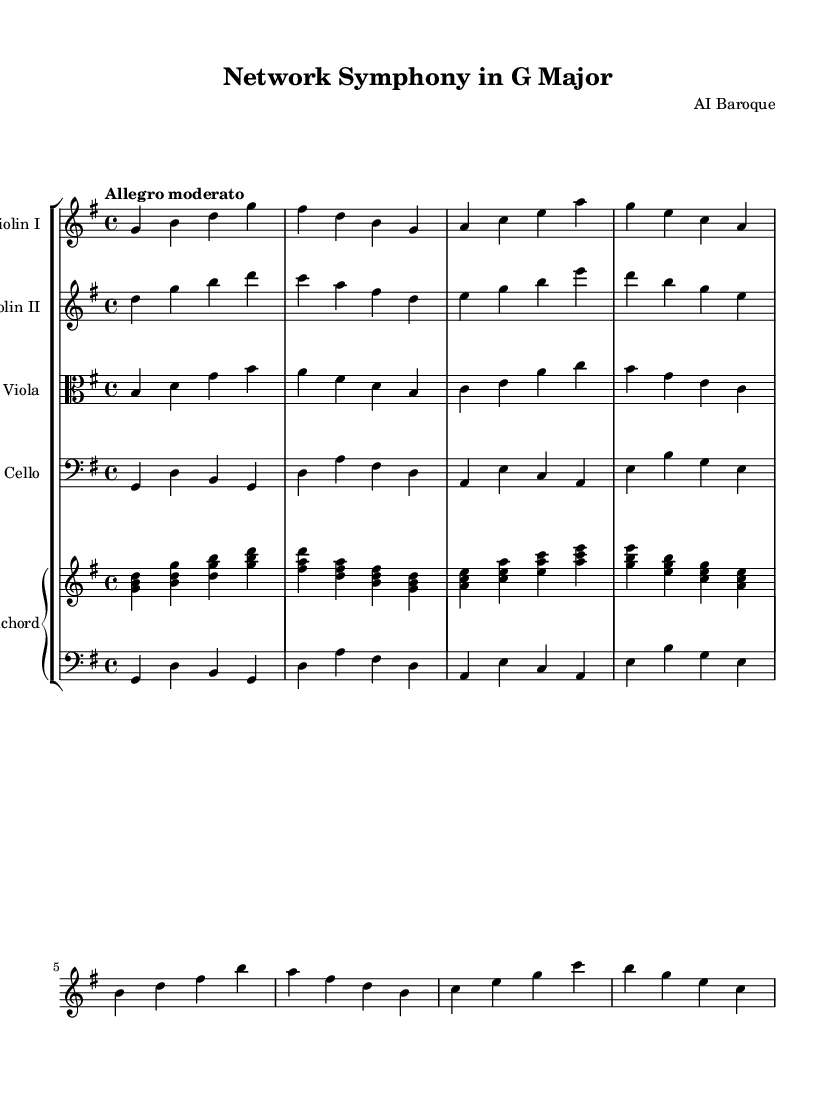What is the key signature of this music? The key signature is G major, which has one sharp (F#). You can determine the key by looking at the key signature at the beginning of the staff, which shows one sharp.
Answer: G major What is the time signature of this music? The time signature is 4/4, which indicates four beats per measure and a quarter note receives one beat. This can be found at the beginning of the score right after the key signature.
Answer: 4/4 What is the tempo marking for this piece? The tempo marking is "Allegro moderato." This information is provided at the beginning of the score and indicates the speed and character at which the piece should be played.
Answer: Allegro moderato How many instruments are featured in this composition? There are five instruments featured in the composition: two violins, one viola, one cello, and one harpsichord. This can be seen at the start of each staff group, where the instruments are named.
Answer: Five Which instrument plays the bass line primarily? The cello primarily plays the bass line in this composition. The music written for the cello is located in the lowest staff, confirming its role in providing the bass foundation.
Answer: Cello What type of musical form is suggested by the variation of textures among the instruments? The music suggests a dialogue or interchange, often found in Baroque chamber music, where the instruments collaboratively explore motifs and interact, creating a network-like structure. This characteristic is evident from the interlocking lines and shared motifs across different instruments.
Answer: Dialogue 